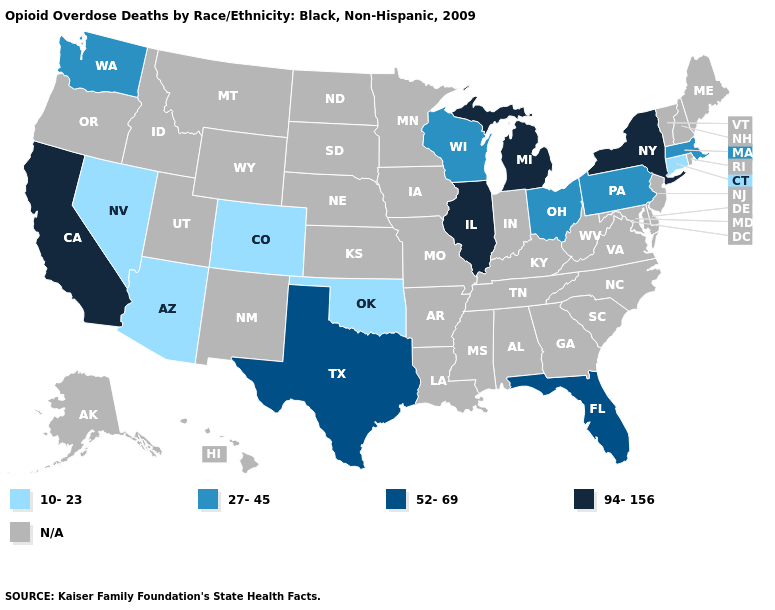Does Florida have the lowest value in the South?
Be succinct. No. Name the states that have a value in the range 94-156?
Give a very brief answer. California, Illinois, Michigan, New York. Name the states that have a value in the range 52-69?
Quick response, please. Florida, Texas. What is the value of Arizona?
Give a very brief answer. 10-23. Name the states that have a value in the range 10-23?
Give a very brief answer. Arizona, Colorado, Connecticut, Nevada, Oklahoma. What is the value of Maine?
Be succinct. N/A. Does Oklahoma have the lowest value in the South?
Keep it brief. Yes. What is the value of Delaware?
Write a very short answer. N/A. What is the value of Maine?
Quick response, please. N/A. Name the states that have a value in the range 27-45?
Concise answer only. Massachusetts, Ohio, Pennsylvania, Washington, Wisconsin. Among the states that border Ohio , does Michigan have the lowest value?
Keep it brief. No. Does Pennsylvania have the highest value in the Northeast?
Write a very short answer. No. 